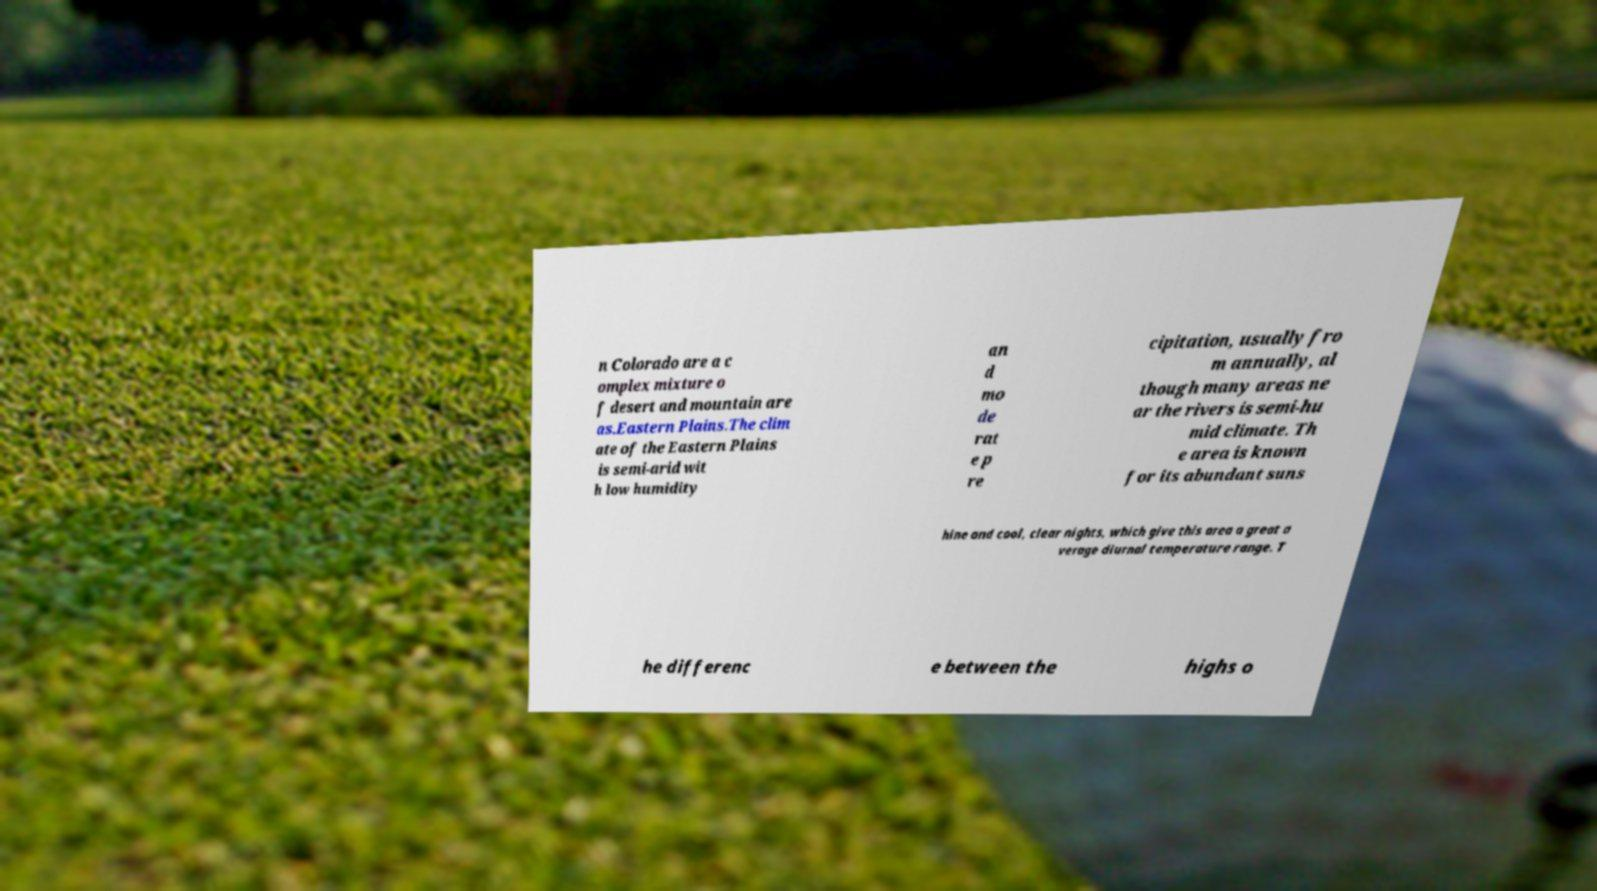Can you accurately transcribe the text from the provided image for me? n Colorado are a c omplex mixture o f desert and mountain are as.Eastern Plains.The clim ate of the Eastern Plains is semi-arid wit h low humidity an d mo de rat e p re cipitation, usually fro m annually, al though many areas ne ar the rivers is semi-hu mid climate. Th e area is known for its abundant suns hine and cool, clear nights, which give this area a great a verage diurnal temperature range. T he differenc e between the highs o 